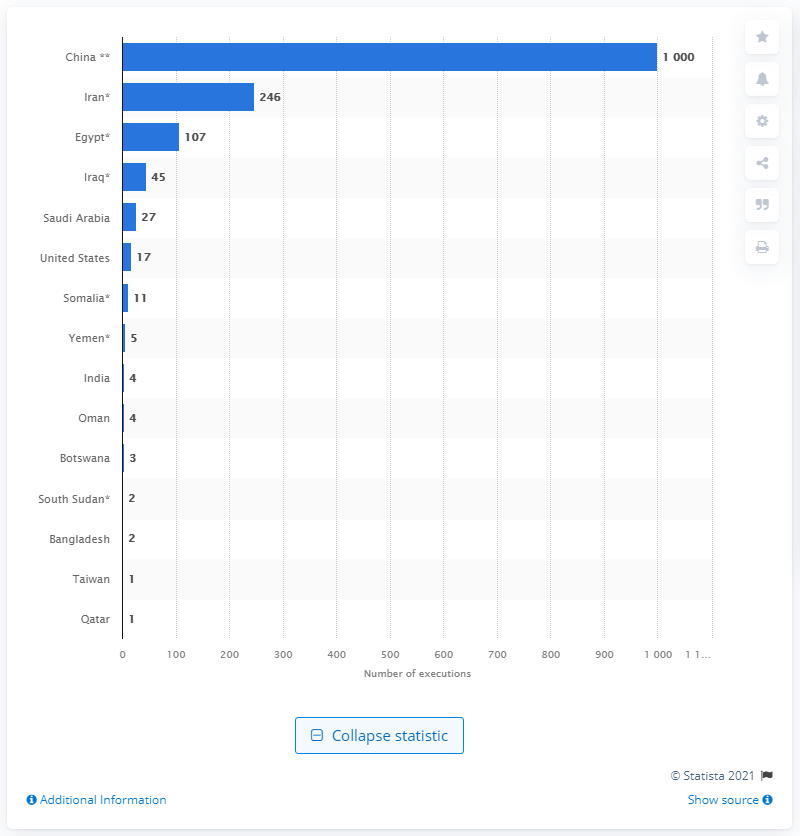Indicate a few pertinent items in this graphic. In 2020, a total of 246 individuals were executed in Iran, according to available records. 